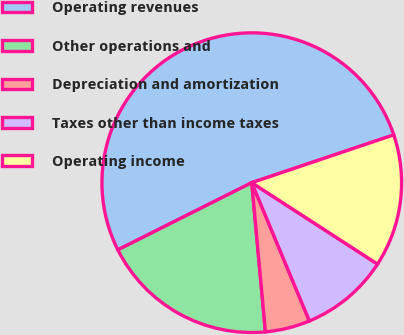Convert chart to OTSL. <chart><loc_0><loc_0><loc_500><loc_500><pie_chart><fcel>Operating revenues<fcel>Other operations and<fcel>Depreciation and amortization<fcel>Taxes other than income taxes<fcel>Operating income<nl><fcel>52.23%<fcel>19.05%<fcel>4.83%<fcel>9.57%<fcel>14.31%<nl></chart> 